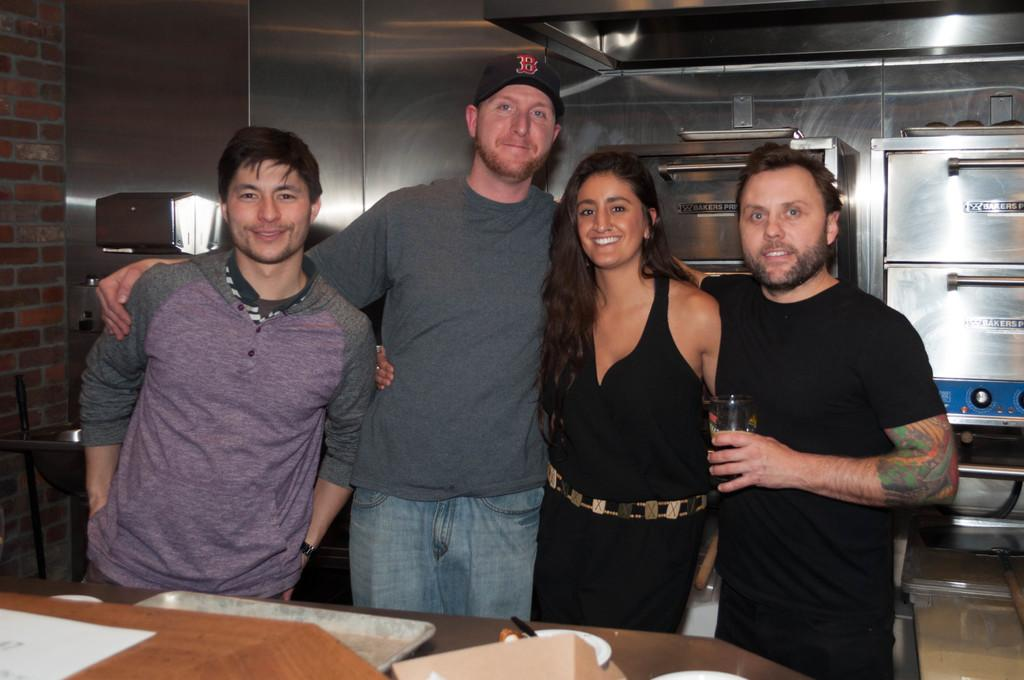How many people are in the image? There are four persons standing in the image. What is one of the persons holding? One of the persons is holding a glass. What else can be seen on the table in the image? There are other objects on the table in the image. What type of stove can be seen in the image? There is no stove present in the image. How many times did the person bite the glass before realizing it was not edible? The image does not show any action of biting the glass, so it cannot be determined from the image. 